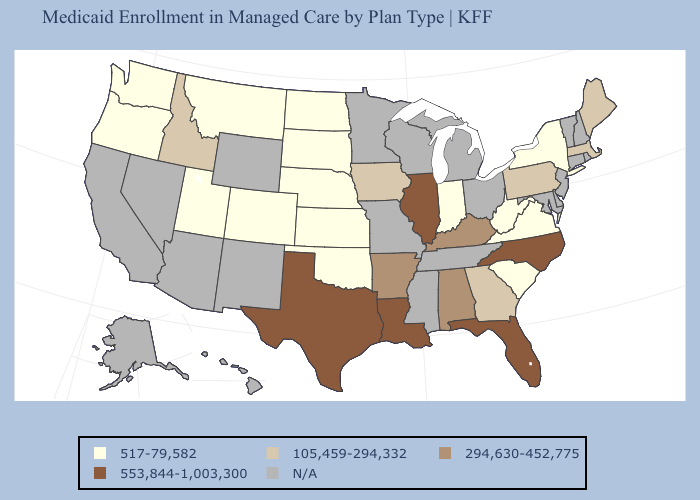What is the lowest value in the Northeast?
Be succinct. 517-79,582. Which states hav the highest value in the West?
Quick response, please. Idaho. Does Nebraska have the lowest value in the MidWest?
Give a very brief answer. Yes. What is the lowest value in states that border South Carolina?
Concise answer only. 105,459-294,332. Which states have the lowest value in the USA?
Short answer required. Colorado, Indiana, Kansas, Montana, Nebraska, New York, North Dakota, Oklahoma, Oregon, South Carolina, South Dakota, Utah, Virginia, Washington, West Virginia. What is the highest value in the USA?
Write a very short answer. 553,844-1,003,300. What is the value of Louisiana?
Concise answer only. 553,844-1,003,300. What is the value of Ohio?
Answer briefly. N/A. What is the lowest value in states that border New Mexico?
Answer briefly. 517-79,582. How many symbols are there in the legend?
Give a very brief answer. 5. What is the value of Connecticut?
Be succinct. N/A. Does Texas have the highest value in the South?
Keep it brief. Yes. 